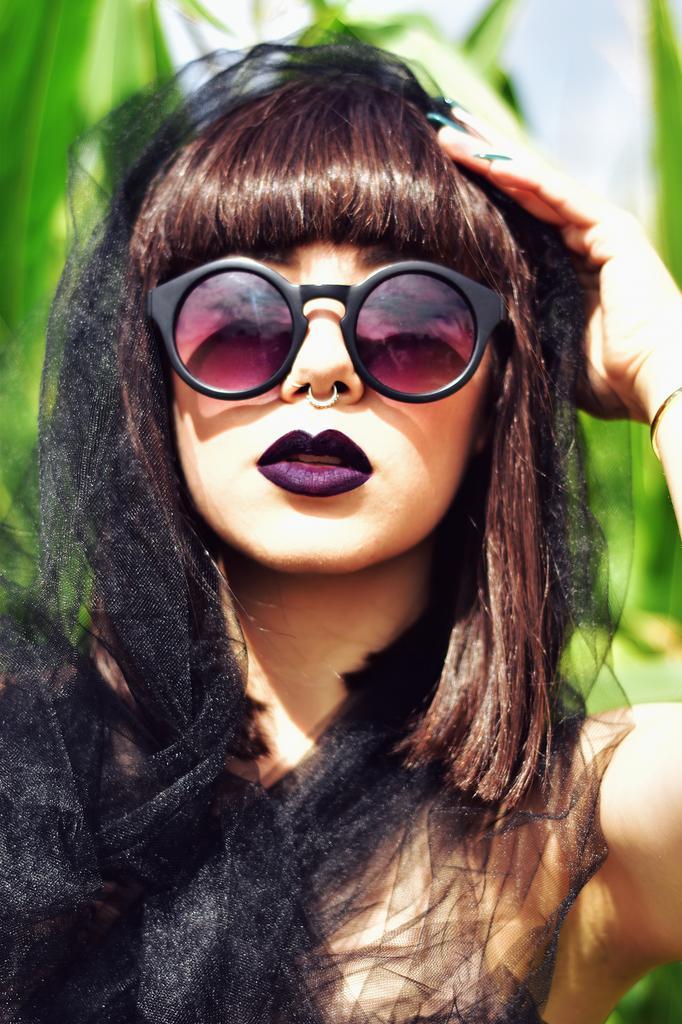Please provide a concise description of this image. In this picture there is a girl in the center of the image, she is wearing glasses. 